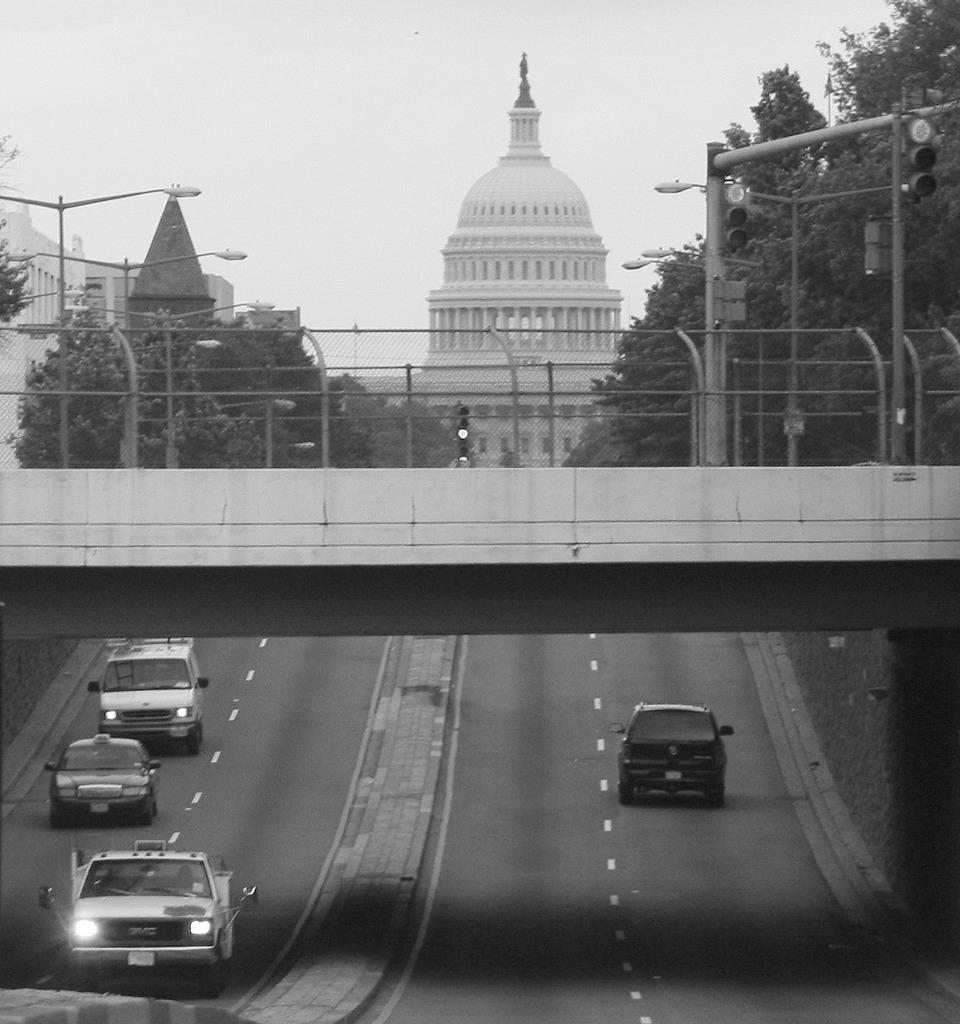What can be seen on the roads in the image? There are vehicles on the roads in the image. What structure is present in the image that allows vehicles to cross over a body of water? There is a bridge in the image. What helps regulate traffic in the image? There are signal lights in the image. What type of lighting is present in the image to illuminate the roads and streets? There are lights attached to poles in the image. What type of natural vegetation can be seen in the image? There are trees in the image. What type of man-made structures can be seen in the image? There are buildings in the image. What part of the natural environment is visible in the image? The sky is visible in the image. What type of smell can be detected coming from the feast in the image? There is no feast present in the image, so no smell can be detected. How does the motion of the vehicles on the roads affect the bridge in the image? The vehicles on the roads do not affect the bridge in the image, as they are separate entities. 